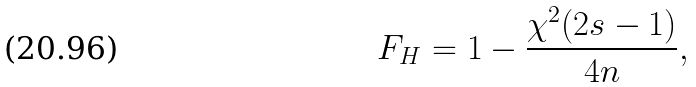<formula> <loc_0><loc_0><loc_500><loc_500>F _ { H } = 1 - \frac { \chi ^ { 2 } ( { 2 s - 1 } ) } { 4 n } ,</formula> 